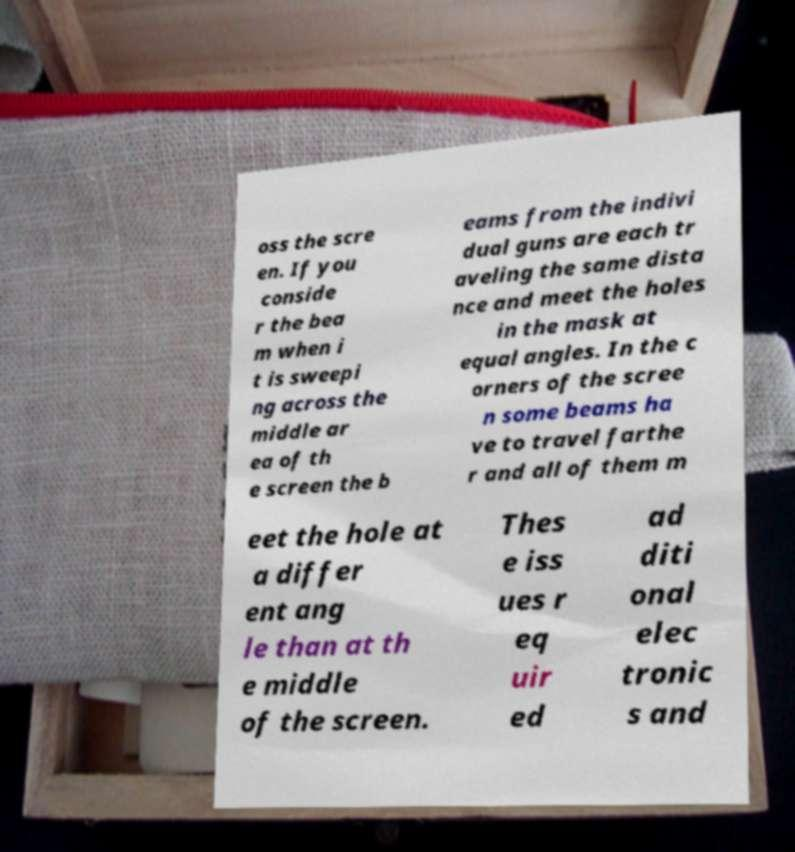Could you extract and type out the text from this image? oss the scre en. If you conside r the bea m when i t is sweepi ng across the middle ar ea of th e screen the b eams from the indivi dual guns are each tr aveling the same dista nce and meet the holes in the mask at equal angles. In the c orners of the scree n some beams ha ve to travel farthe r and all of them m eet the hole at a differ ent ang le than at th e middle of the screen. Thes e iss ues r eq uir ed ad diti onal elec tronic s and 